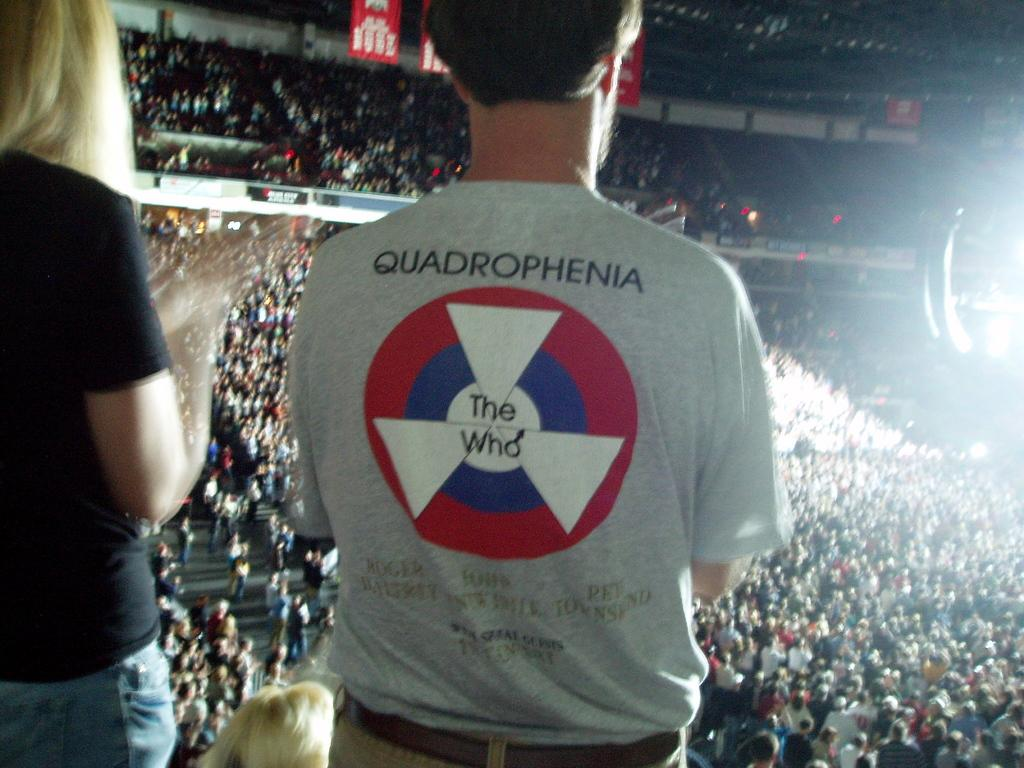How many people are present in the image? There are two people, a man and a woman, present in the image. What is the man wearing in the image? The man is wearing a t-shirt with a logo in the image. What can be seen on the man's t-shirt? There is something written on the man's t-shirt in the image. What is visible in the background of the image? There is a crowd, banners, and light visible in the background of the image. What type of string is being used to hold the tomatoes in the image? There are no tomatoes or string present in the image. How many spades are visible in the image? There are no spades visible in the image. 